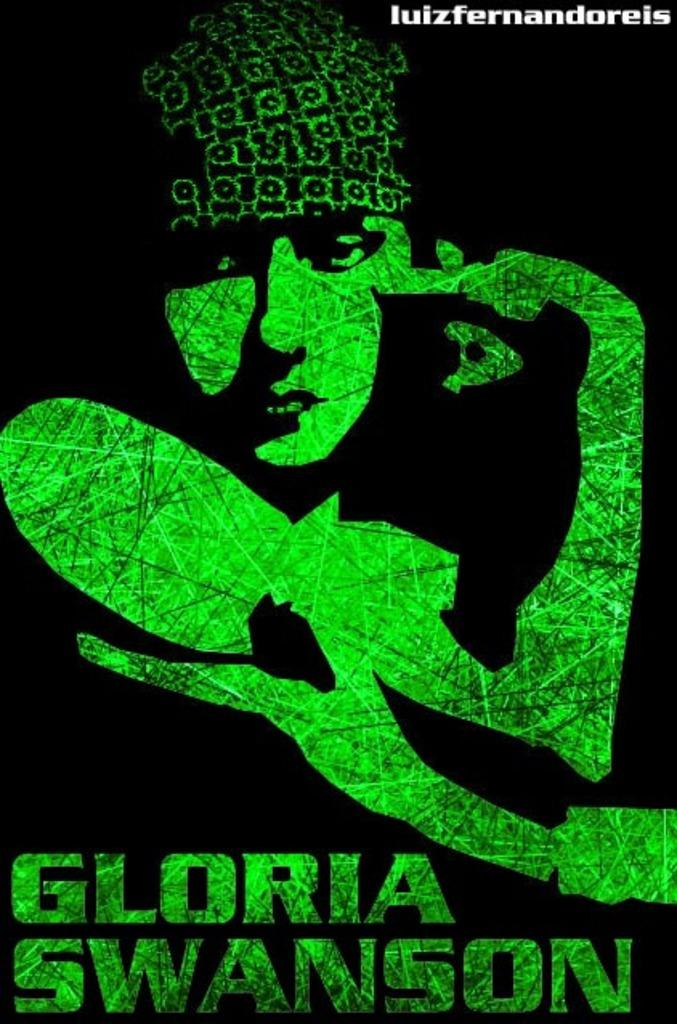What is the main subject of the image? There is some art in the image. Can you describe the art in more detail? The art has text written on it. What color is the background of the image? The background of the image appears to be black. Can you see any mountains in the image? There are no mountains present in the image; it features art with text on a black background. What type of cheese is depicted in the art? There is no cheese present in the image; it features art with text on a black background. 